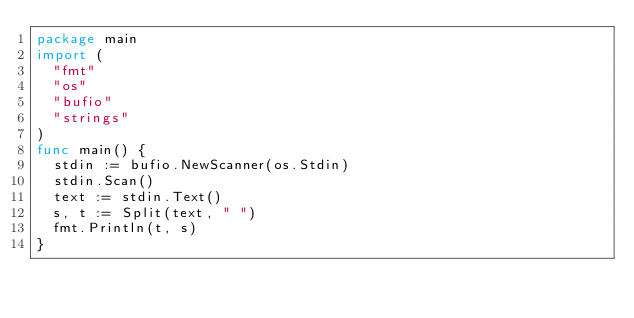Convert code to text. <code><loc_0><loc_0><loc_500><loc_500><_Go_>package main
import (
  "fmt"
  "os"
  "bufio"
  "strings"
)
func main() {
  stdin := bufio.NewScanner(os.Stdin)
  stdin.Scan()
  text := stdin.Text()
  s, t := Split(text, " ")
  fmt.Println(t, s)
}
</code> 